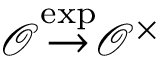Convert formula to latex. <formula><loc_0><loc_0><loc_500><loc_500>{ \mathcal { O } } { \stackrel { \exp } { \to } } { \mathcal { O } } ^ { \times }</formula> 